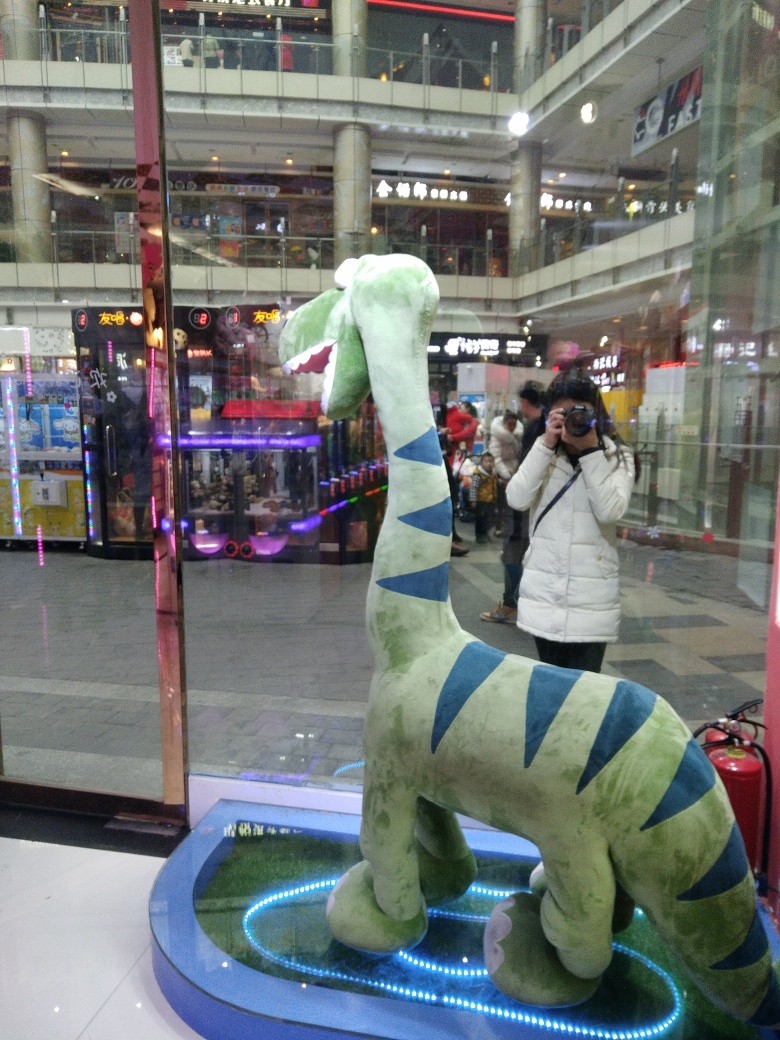The setting appears to be an arcade – what kind of atmosphere does the image convey about the place? The image exudes a vibrant but slightly chaotic atmosphere typical of arcades. The kaleidoscope of colors, bright lights, and reflections suggest a bustling environment full of energy and activity, where people come to escape the mundane and dive into a world of playful escapism. How does the inclusion of surrounding games and machines impact the composition of the photo? The surrounding arcade machines and bright neon lights contribute to a visual cacophony that frames the dinosaur. They create a chaotic backdrop that makes the subject stand out in contrast. This juxtaposition draws the viewer's attention directly to the plush figure, emphasizing its centrality in the photograph. 